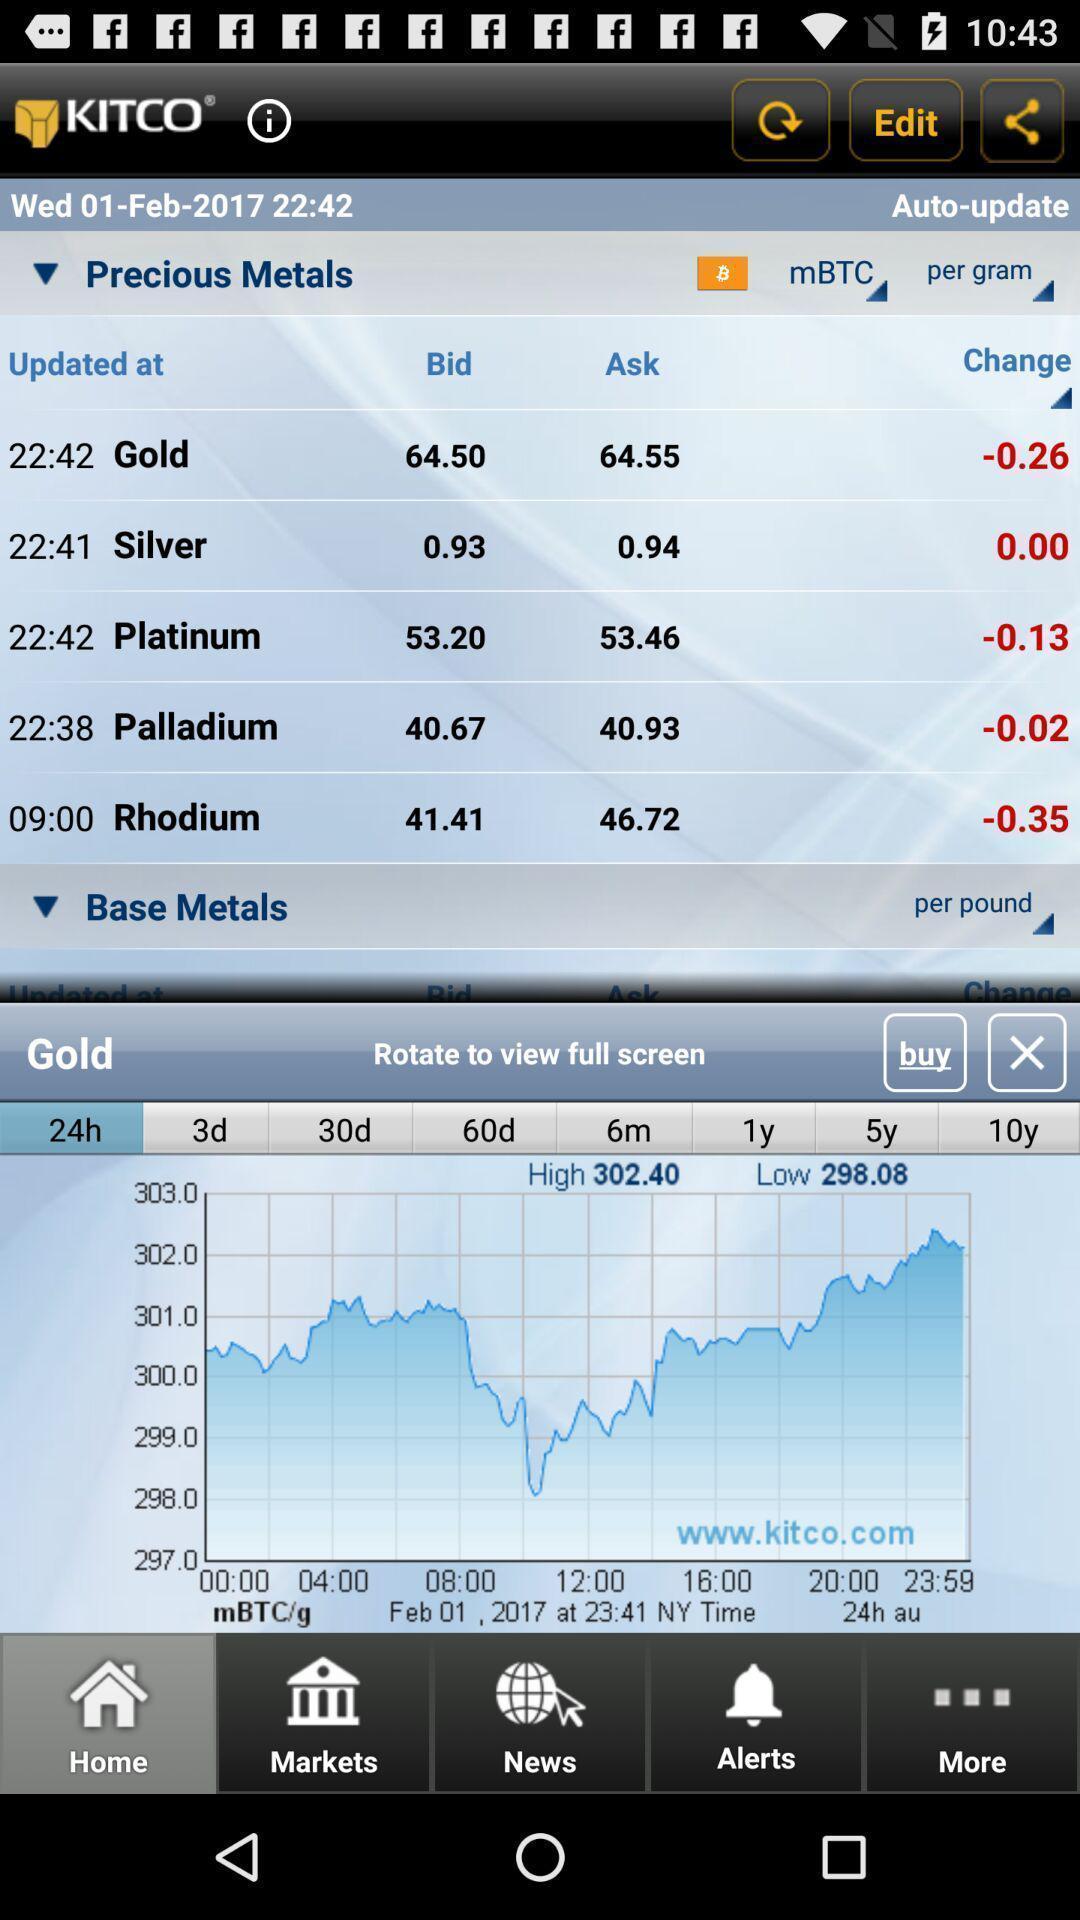Give me a narrative description of this picture. Screen shows metals graph range details. 